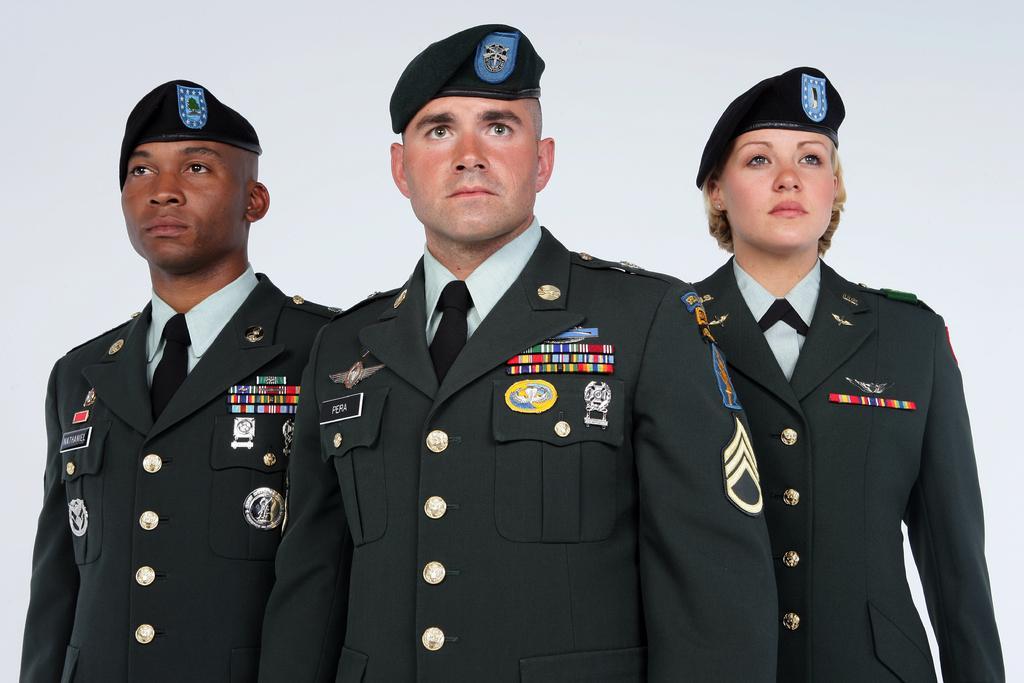Can you describe this image briefly? In this image, we can see persons wearing clothes and caps. 